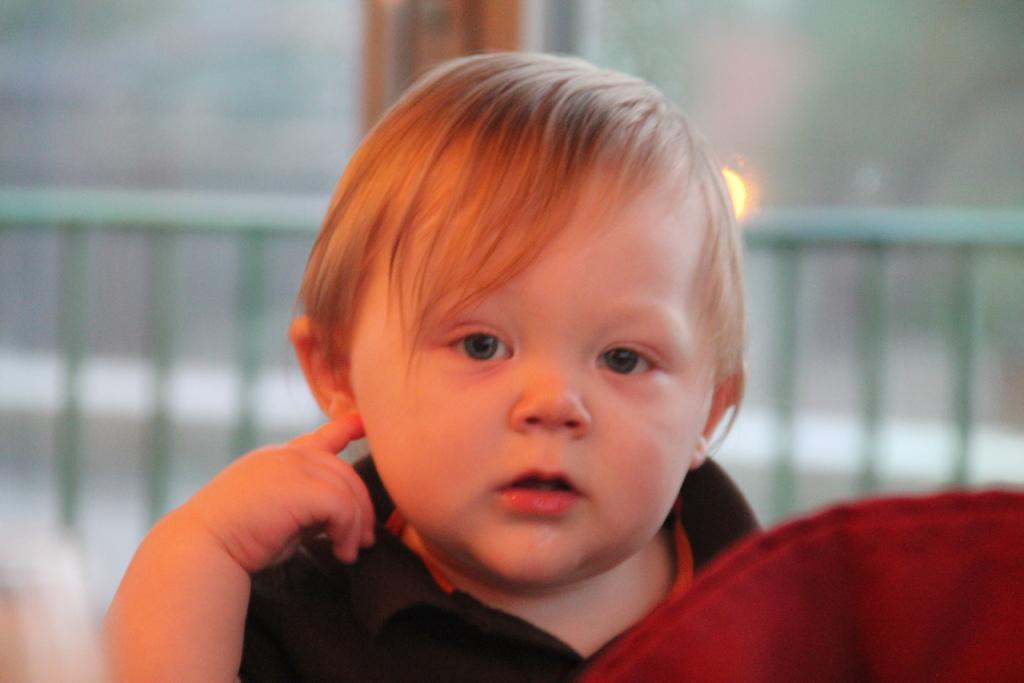Could you give a brief overview of what you see in this image? In this picture we can see a kid, in the background we can find few metal rods. 